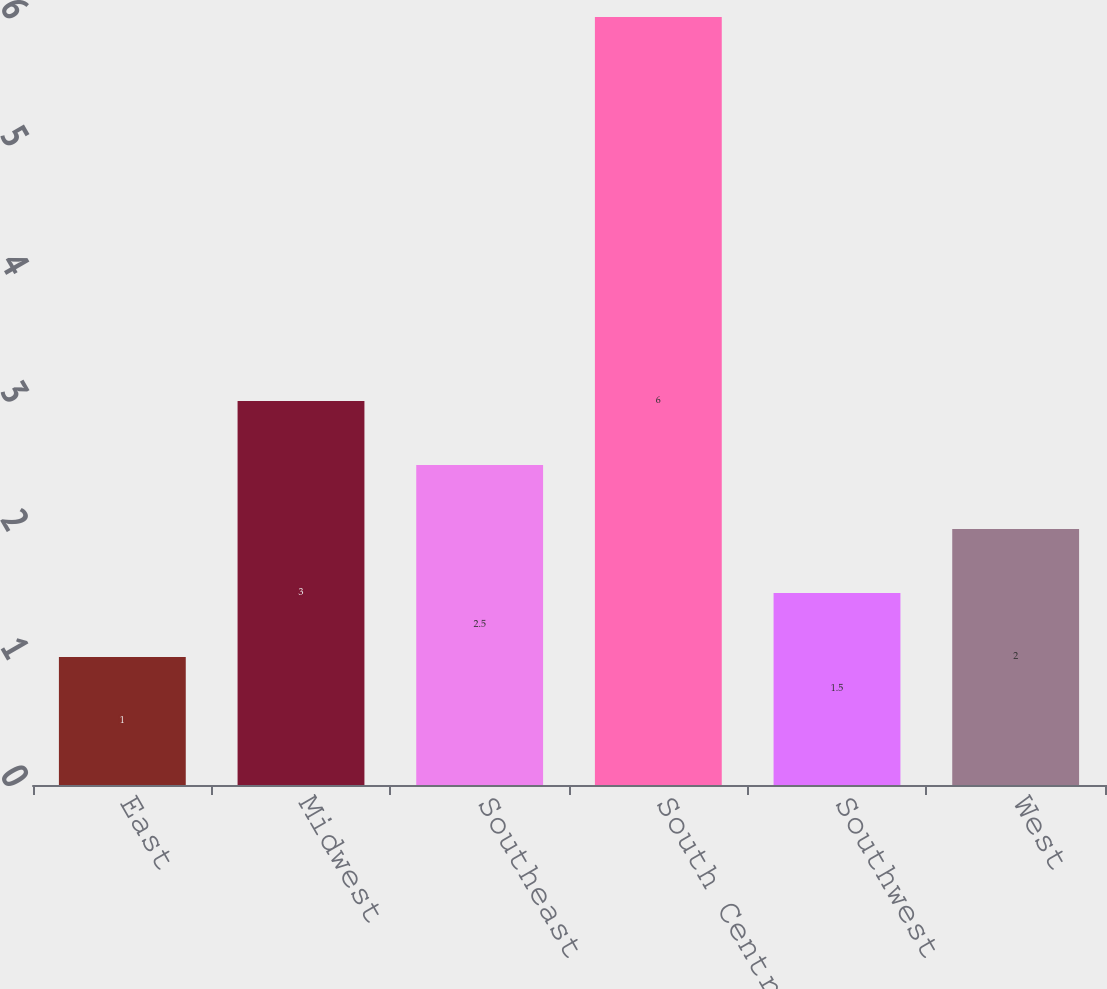Convert chart to OTSL. <chart><loc_0><loc_0><loc_500><loc_500><bar_chart><fcel>East<fcel>Midwest<fcel>Southeast<fcel>South Central<fcel>Southwest<fcel>West<nl><fcel>1<fcel>3<fcel>2.5<fcel>6<fcel>1.5<fcel>2<nl></chart> 